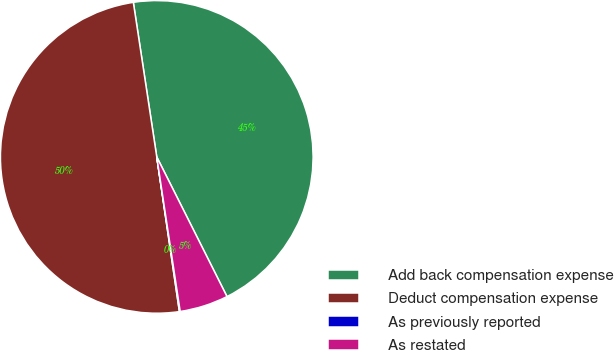<chart> <loc_0><loc_0><loc_500><loc_500><pie_chart><fcel>Add back compensation expense<fcel>Deduct compensation expense<fcel>As previously reported<fcel>As restated<nl><fcel>44.98%<fcel>49.92%<fcel>0.08%<fcel>5.02%<nl></chart> 